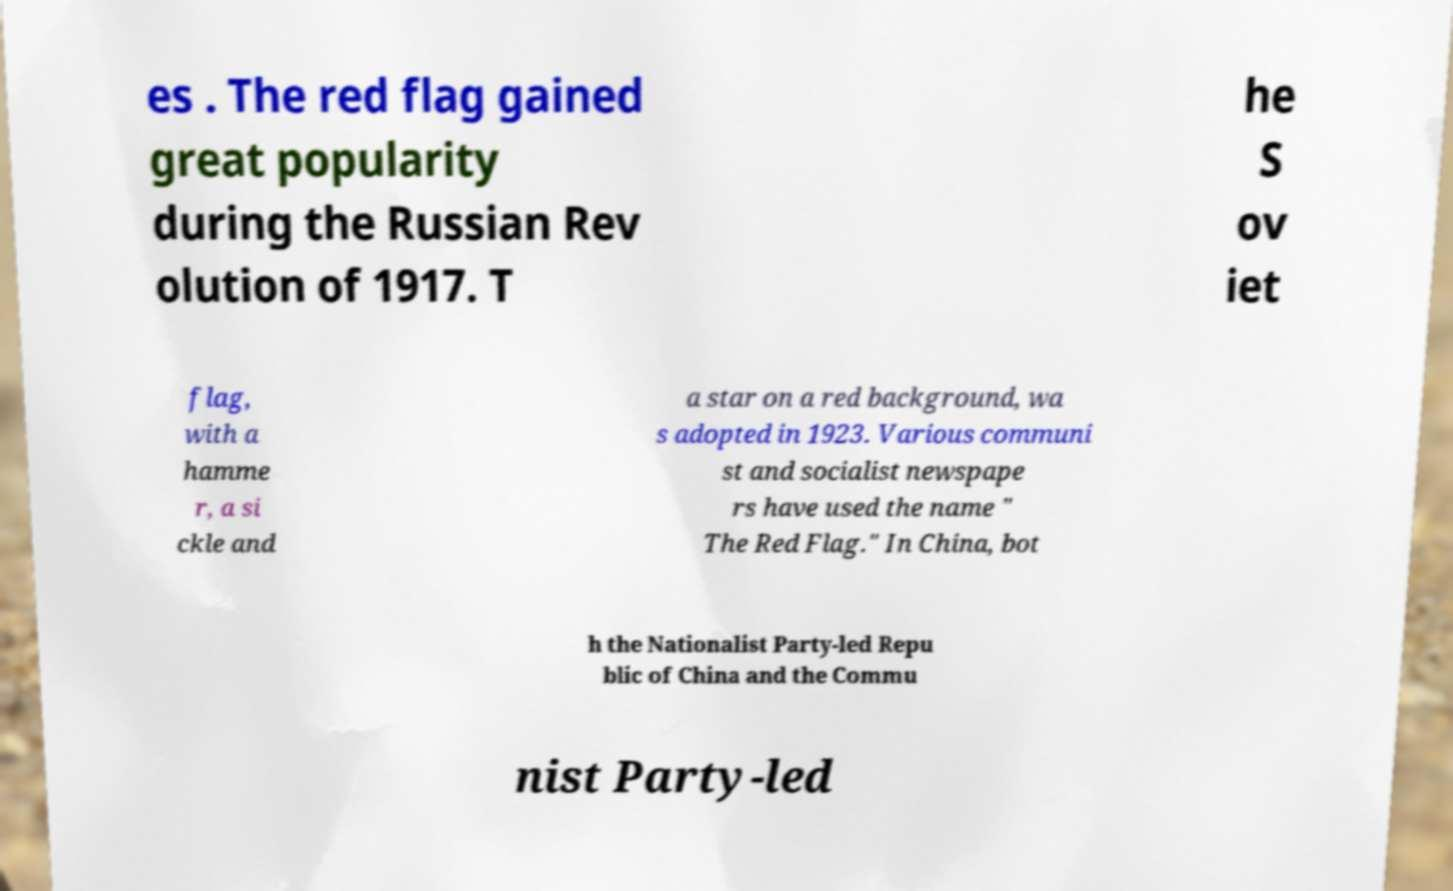Can you accurately transcribe the text from the provided image for me? es . The red flag gained great popularity during the Russian Rev olution of 1917. T he S ov iet flag, with a hamme r, a si ckle and a star on a red background, wa s adopted in 1923. Various communi st and socialist newspape rs have used the name " The Red Flag." In China, bot h the Nationalist Party-led Repu blic of China and the Commu nist Party-led 